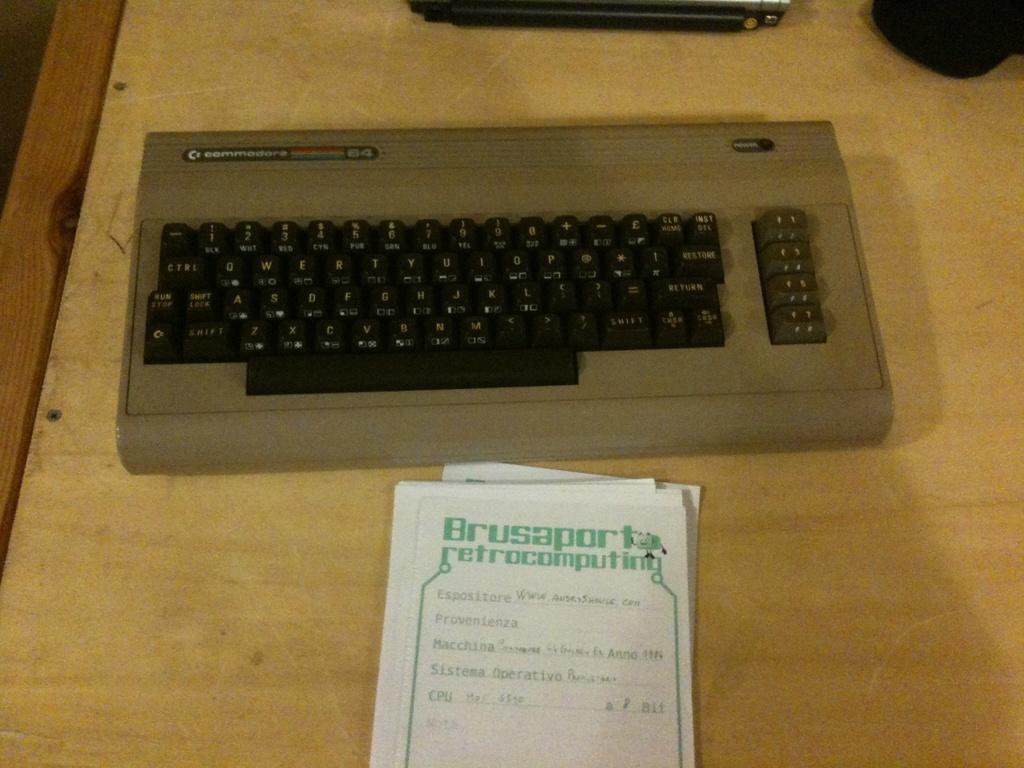What does the paper say?
Keep it short and to the point. Brusaport retrocomputing. What brand keyboard is this?
Offer a terse response. Commodore. 